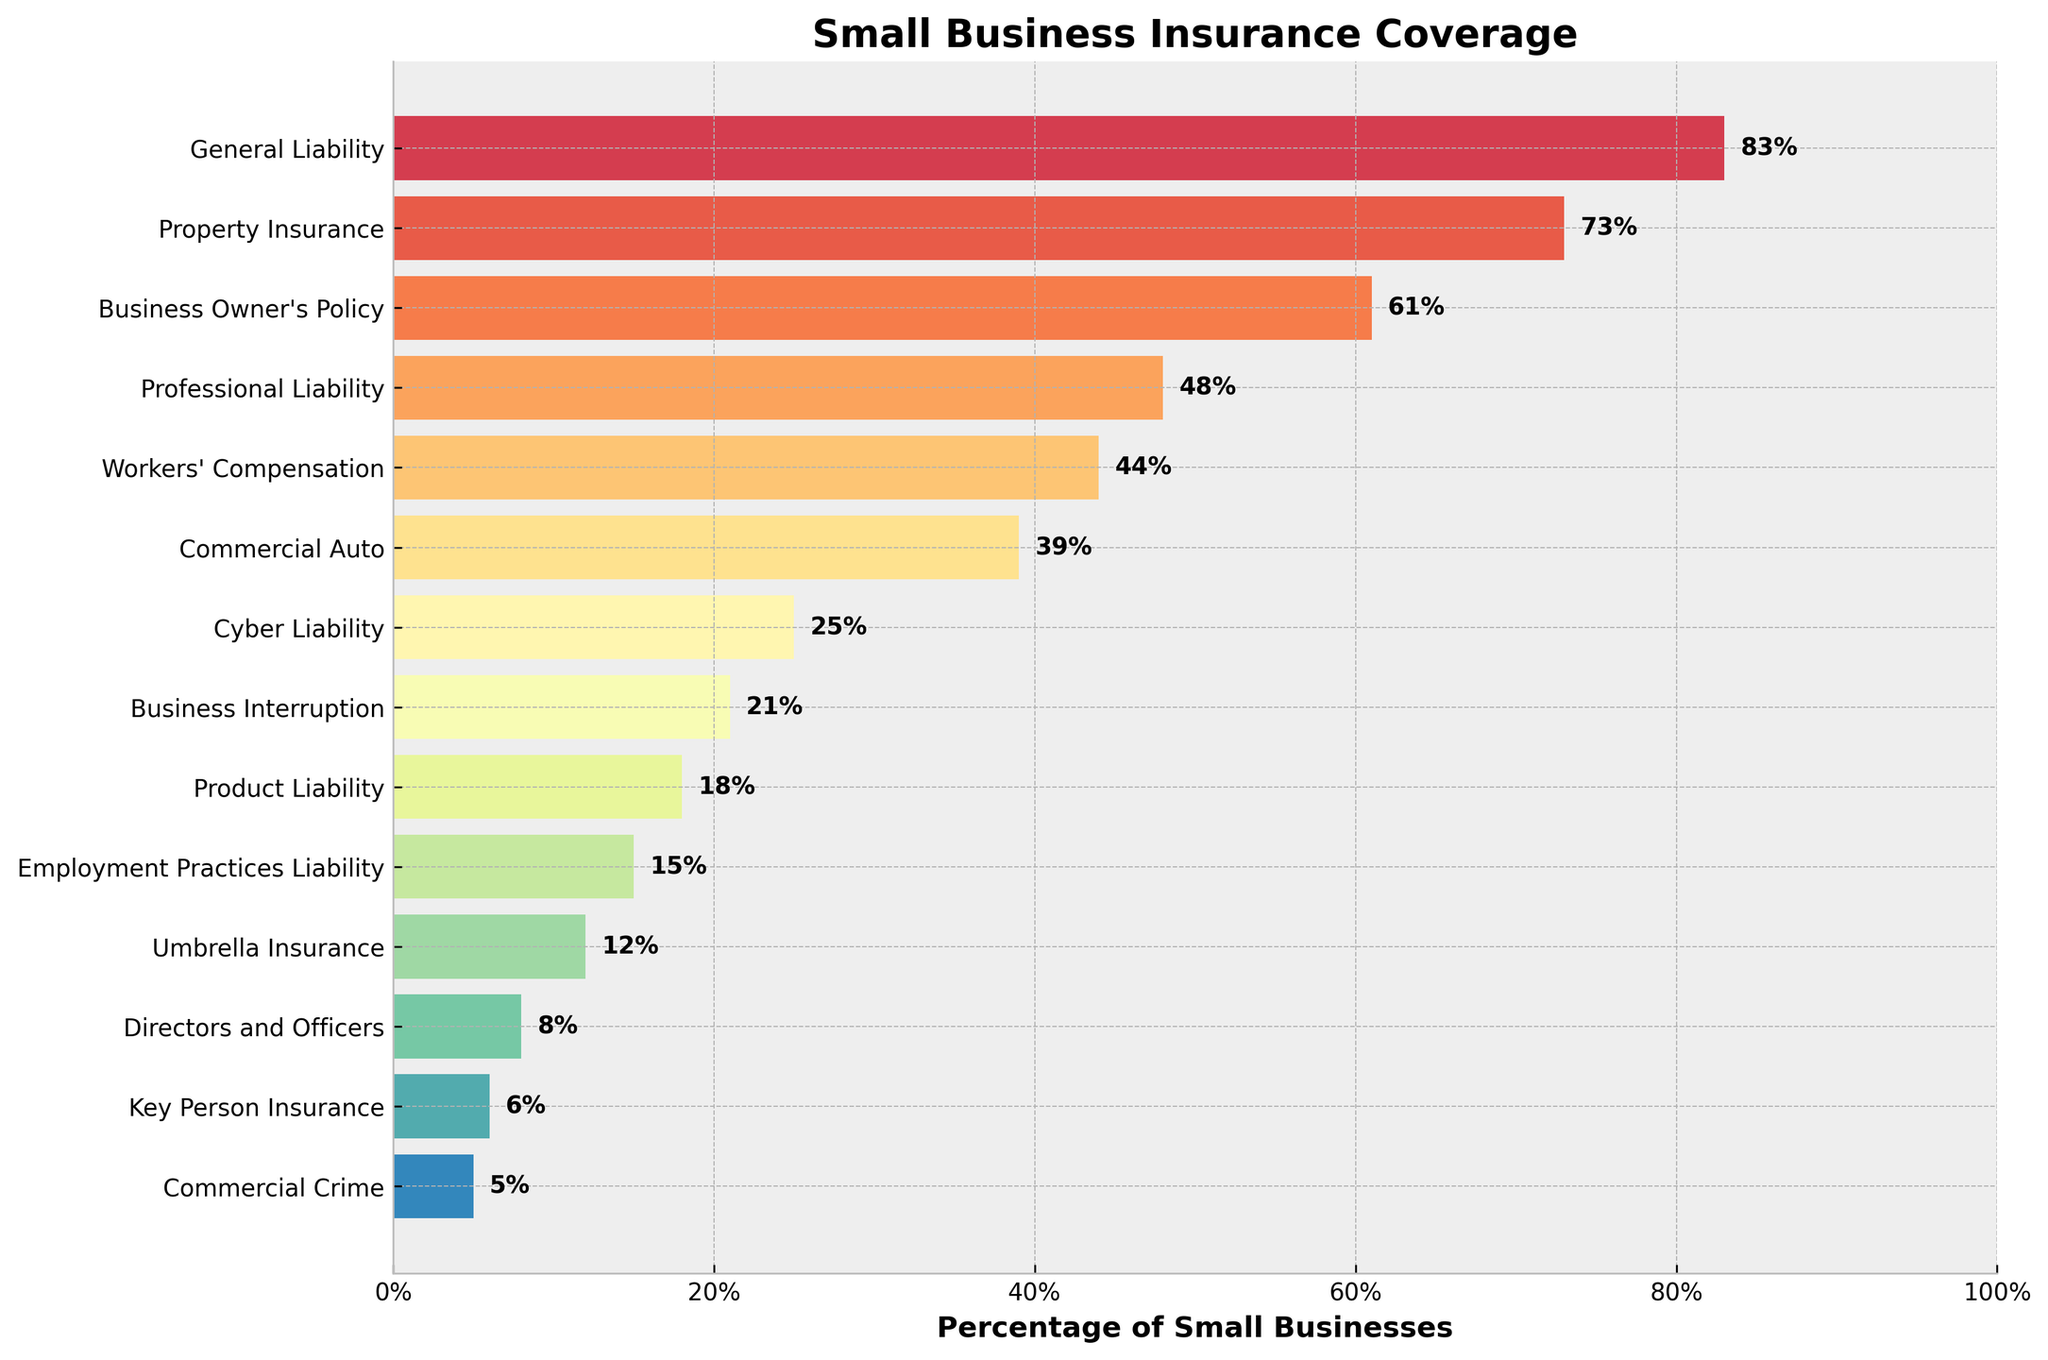Which type of insurance has the highest percentage of coverage among small businesses? The highest bar represents General Liability insurance with a height reaching 83%.
Answer: General Liability What is the difference in coverage percentage between Property Insurance and Cyber Liability insurance? Property Insurance has 73% coverage and Cyber Liability insurance has 25%. The difference is 73% - 25% = 48%.
Answer: 48% Which insurance type has the lowest coverage percentage? The smallest bar corresponds to Commercial Crime insurance, which occupies 5% on the chart.
Answer: Commercial Crime How many insurance types have coverage percentages greater than 50%? General Liability (83%), Property Insurance (73%), and Business Owner's Policy (61%) all have percentages above 50%.
Answer: 3 What is the total percentage of coverage for the bottom three insurance types? The bottom three are Key Person Insurance (6%), Commercial Crime (5%), and Directors and Officers (8%). The total is 6% + 5% + 8% = 19%.
Answer: 19% Compare the coverage percentage of Business Interruption and Workers' Compensation insurance. Which is higher and by how much? Business Interruption has 21% coverage, while Workers' Compensation has 44%. Workers' Compensation is higher by 44% - 21% = 23%.
Answer: Workers' Compensation, 23% Which insurance types have coverage percentages that fall between 20% and 50%? Professional Liability (48%), Workers' Compensation (44%), and Commercial Auto (39%), Cyber Liability (25%), and Business Interruption (21%) fall within this range.
Answer: Professional Liability, Workers' Compensation, Commercial Auto, Cyber Liability, Business Interruption What is the median coverage percentage among all the listed insurance types? The percentages in ascending order are: 5, 6, 8, 12, 15, 18, 21, 25, 39, 44, 48, 61, 73, 83. The median is the middle value, which is 21%.
Answer: 21% How many insurance types have a coverage percentage less than the mean of all listed types? The mean is calculated as the sum of all percentages divided by the number of types (14). Sum: 481, mean: 481 / 14 ≈ 34.4. Types below this mean: Employment Practices Liability, Cyber Liability, Business Interruption, Product Liability, Directors and Officers, Key Person Insurance, Commercial Crime, and Umbrella Insurance. There are 8 types.
Answer: 8 